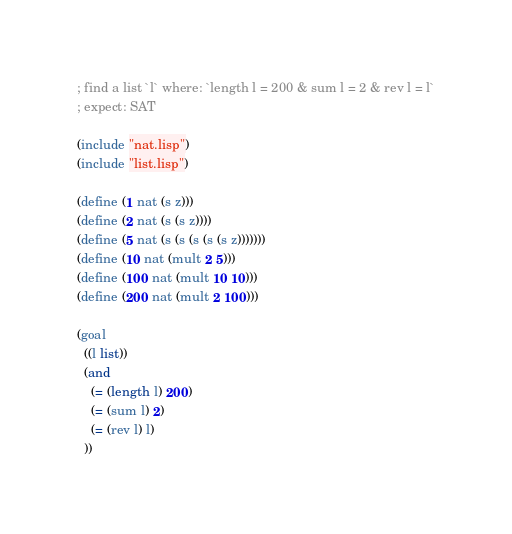<code> <loc_0><loc_0><loc_500><loc_500><_Lisp_>
; find a list `l` where: `length l = 200 & sum l = 2 & rev l = l`
; expect: SAT

(include "nat.lisp")
(include "list.lisp")

(define (1 nat (s z)))
(define (2 nat (s (s z))))
(define (5 nat (s (s (s (s (s z)))))))
(define (10 nat (mult 2 5)))
(define (100 nat (mult 10 10)))
(define (200 nat (mult 2 100)))

(goal
  ((l list))
  (and
    (= (length l) 200)
    (= (sum l) 2)
    (= (rev l) l)
  ))


</code> 